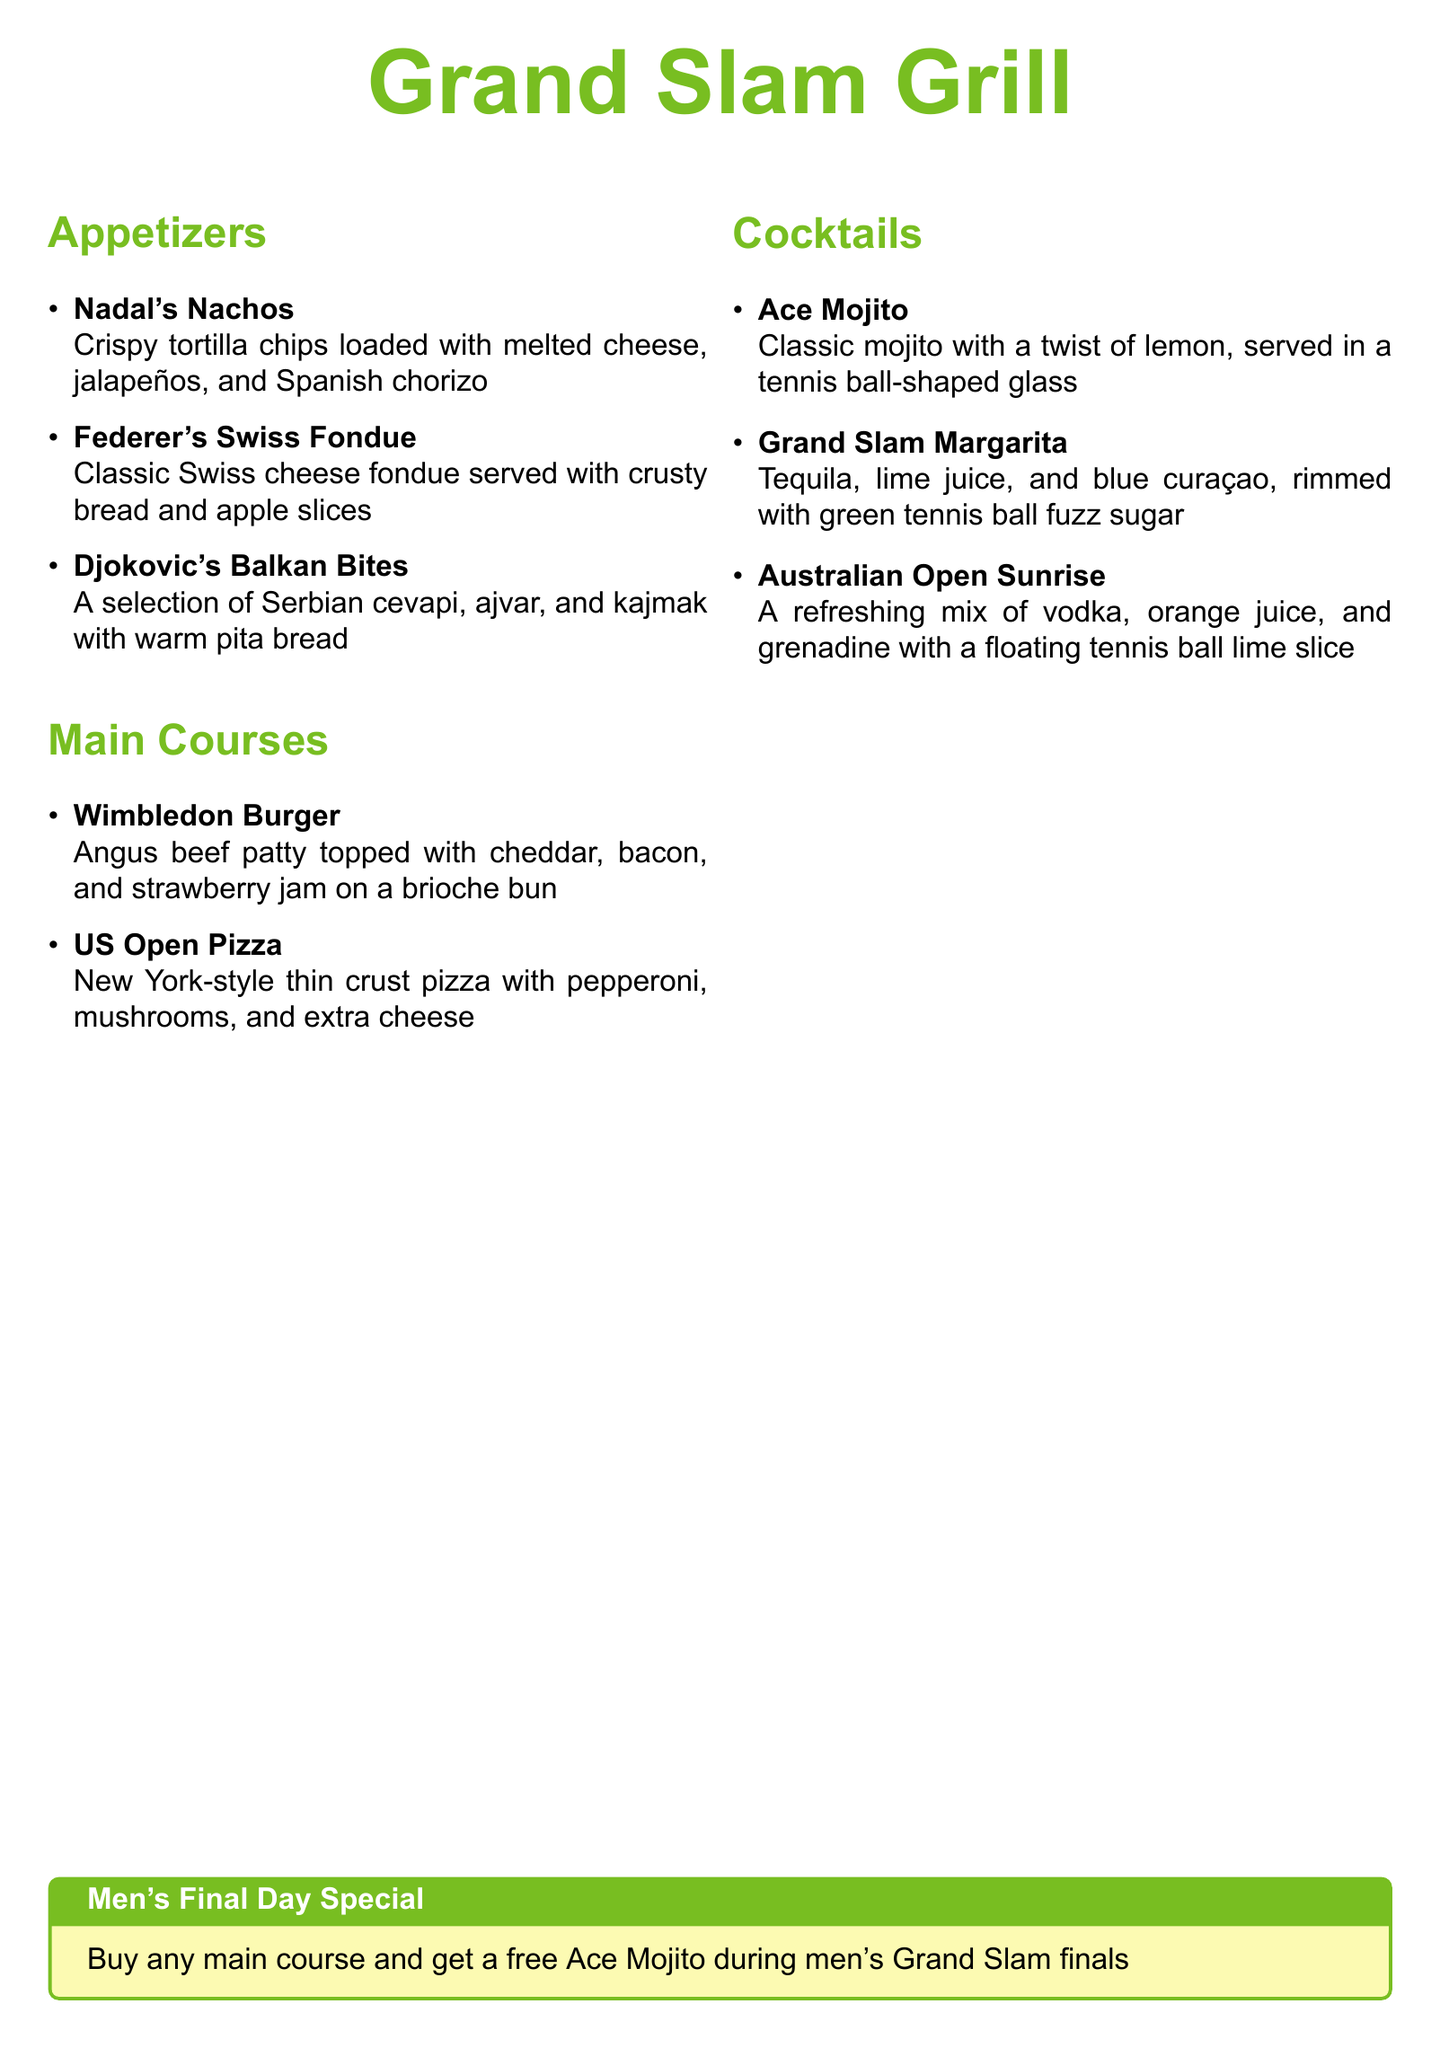What is the name of the restaurant? The name of the restaurant is prominently displayed at the top of the menu.
Answer: Grand Slam Grill What appetizer features chorizo? The specific appetizer that includes chorizo is mentioned in the appetizers section.
Answer: Nadal's Nachos What main course is associated with Wimbledon? The main course linked to Wimbledon is listed under main courses.
Answer: Wimbledon Burger How many appetizers are listed on the menu? The total number of appetizers can be counted from the appetizers section.
Answer: 3 What is the special cocktail for men's Grand Slam finals? The special offer related to cocktails during finals is highlighted in the document.
Answer: Ace Mojito Which cocktail has blue curaçao? The cocktail that includes blue curaçao is found in the cocktails section.
Answer: Grand Slam Margarita What is offered for free with a main course on men's final day? The promotion for men's final day includes a specific item that is free with a main course.
Answer: Ace Mojito What type of pizza is mentioned on the menu? The style of pizza is indicated in the main courses section.
Answer: New York-style thin crust pizza 